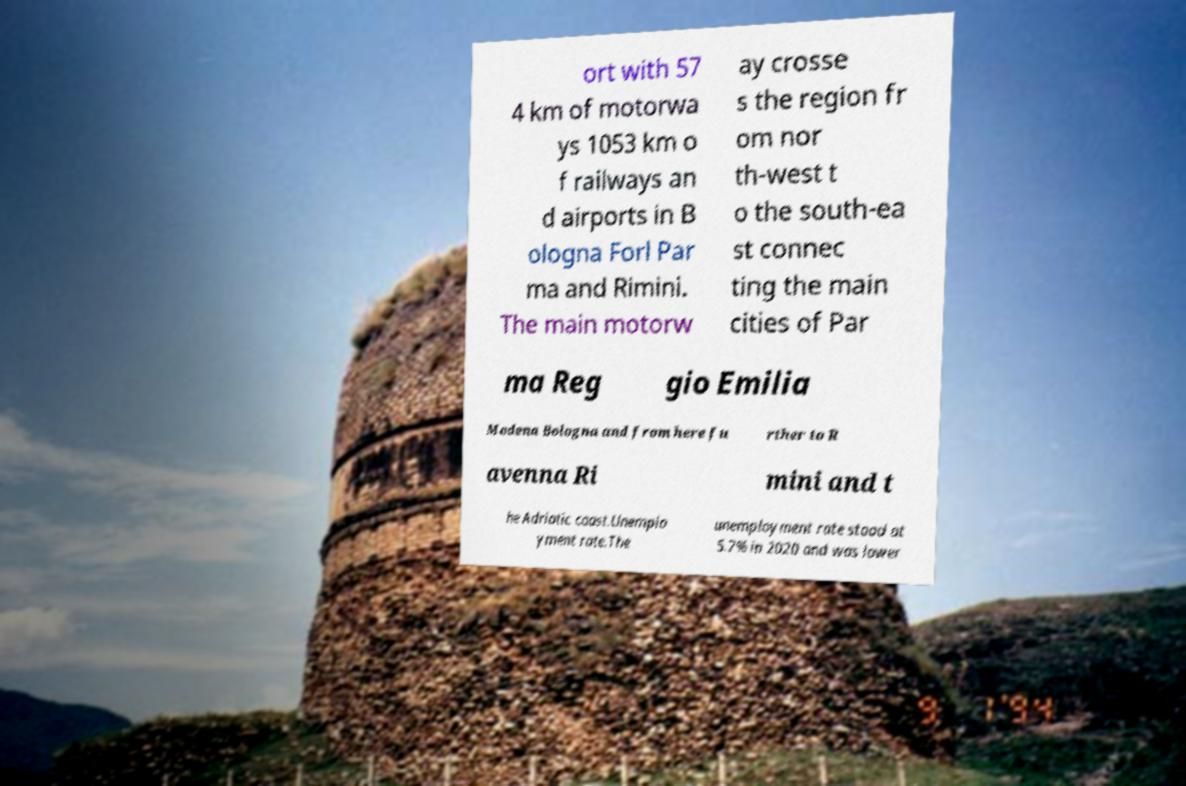What messages or text are displayed in this image? I need them in a readable, typed format. ort with 57 4 km of motorwa ys 1053 km o f railways an d airports in B ologna Forl Par ma and Rimini. The main motorw ay crosse s the region fr om nor th-west t o the south-ea st connec ting the main cities of Par ma Reg gio Emilia Modena Bologna and from here fu rther to R avenna Ri mini and t he Adriatic coast.Unemplo yment rate.The unemployment rate stood at 5.7% in 2020 and was lower 